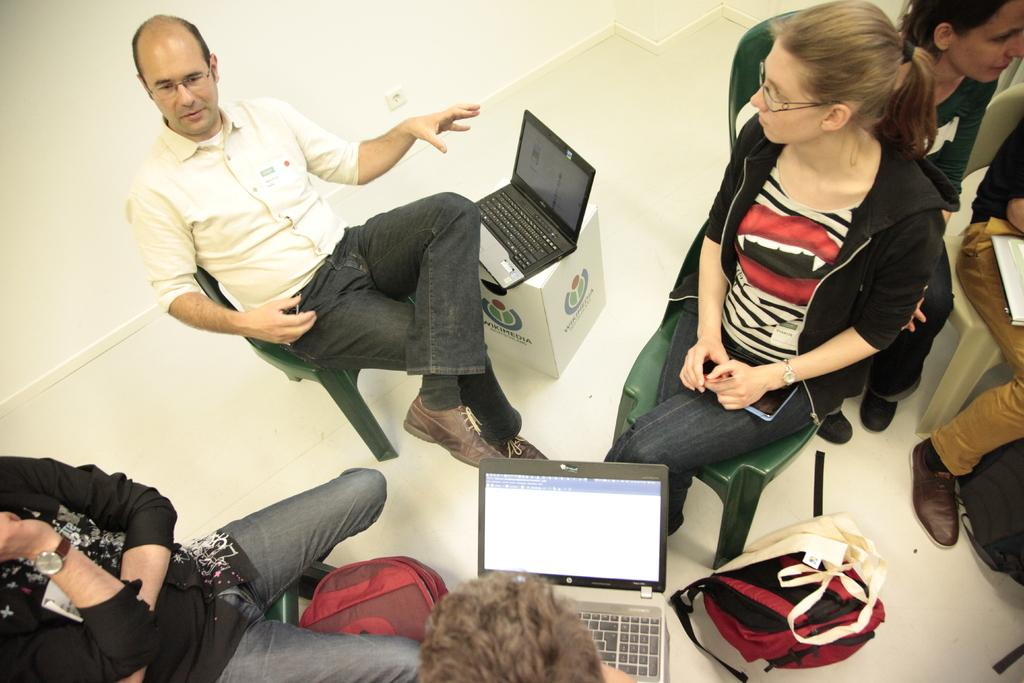What are the people in the image doing? The people in the image are sitting on chairs. What can be seen on top of a box in the image? There is a system (likely an electronic device) placed on a box. Are there any other systems visible in the image? Yes, there is another system visible in the image. What objects can be seen at the bottom of the image? Bags are present at the bottom of the image. What type of salt is being used to play music in the image? There is no salt or music present in the image. 